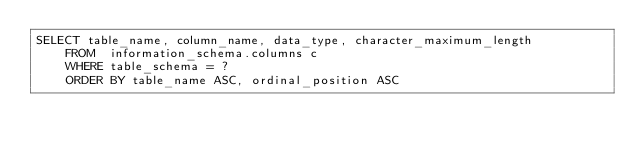Convert code to text. <code><loc_0><loc_0><loc_500><loc_500><_SQL_>SELECT table_name, column_name, data_type, character_maximum_length
    FROM  information_schema.columns c
    WHERE table_schema = ?
    ORDER BY table_name ASC, ordinal_position ASC
</code> 